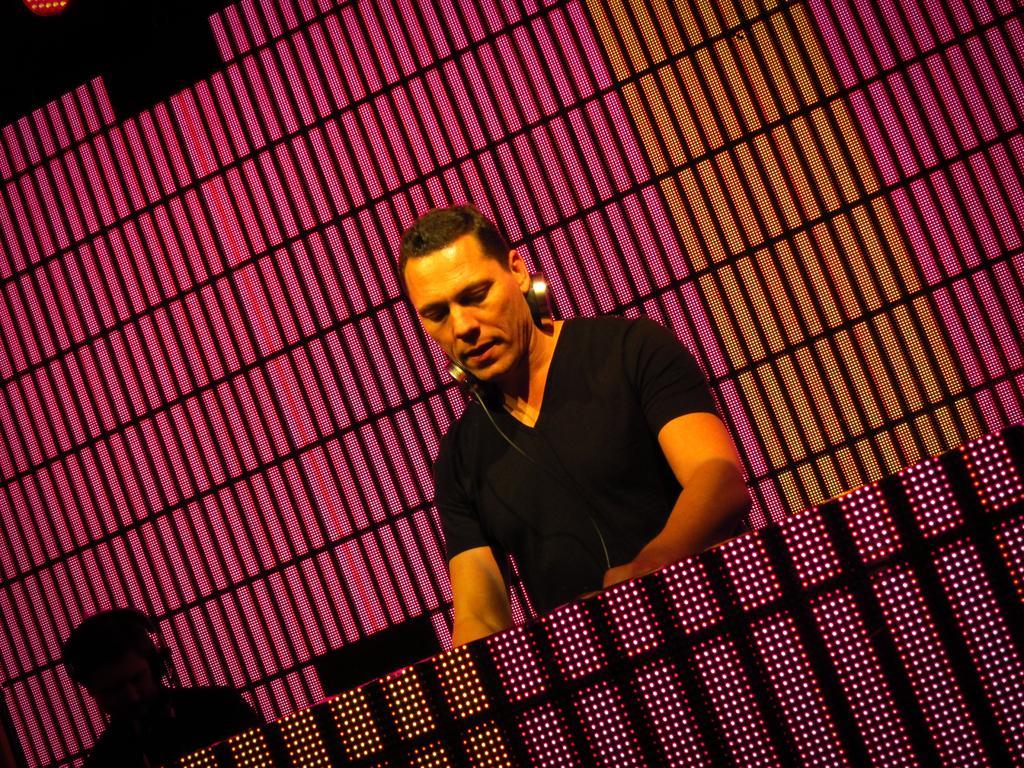Could you give a brief overview of what you see in this image? In this picture there are two persons with headphones and at the back it looks like a chair and there is a screen. In the foreground it looks like a table. 